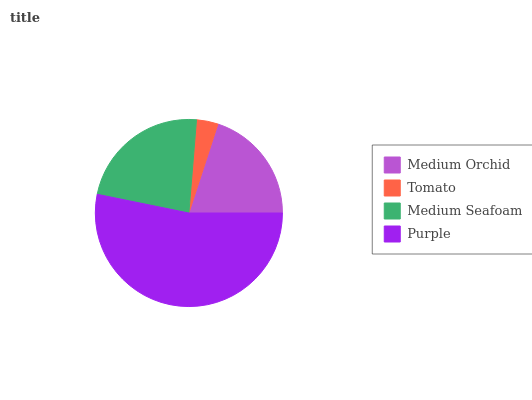Is Tomato the minimum?
Answer yes or no. Yes. Is Purple the maximum?
Answer yes or no. Yes. Is Medium Seafoam the minimum?
Answer yes or no. No. Is Medium Seafoam the maximum?
Answer yes or no. No. Is Medium Seafoam greater than Tomato?
Answer yes or no. Yes. Is Tomato less than Medium Seafoam?
Answer yes or no. Yes. Is Tomato greater than Medium Seafoam?
Answer yes or no. No. Is Medium Seafoam less than Tomato?
Answer yes or no. No. Is Medium Seafoam the high median?
Answer yes or no. Yes. Is Medium Orchid the low median?
Answer yes or no. Yes. Is Tomato the high median?
Answer yes or no. No. Is Purple the low median?
Answer yes or no. No. 